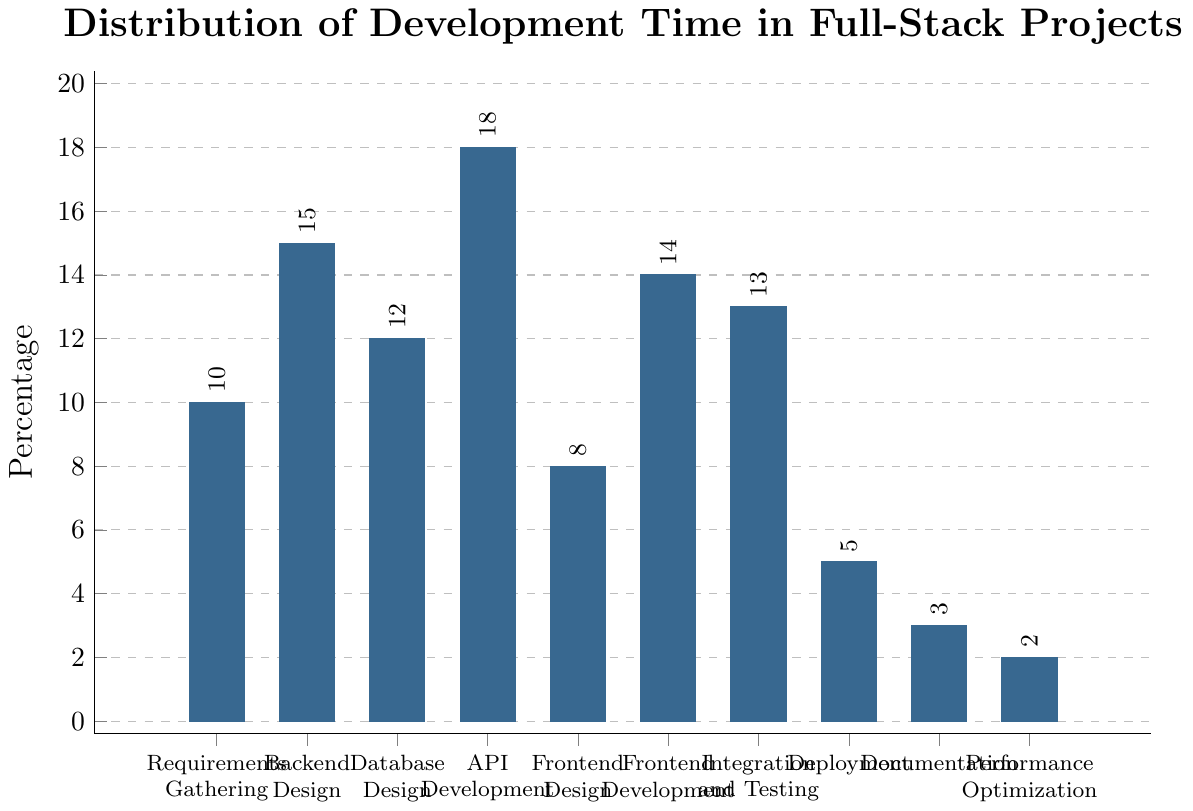What is the highest percentage phase in the development time distribution? The bar representing **API Development** reaches the highest point, indicating it takes up the most significant percentage of the development time. By visually comparing the heights of the bars, we can determine that API Development has the highest percentage.
Answer: API Development Which phase has the lowest percentage in the development time distribution? The shortest bar in the chart represents **Performance Optimization**, indicating that this phase has the lowest percentage of development time. By comparing the heights of all bars, Performance Optimization's is clearly the lowest.
Answer: Performance Optimization How much more time is spent on Backend Design compared to Deployment? The height of the bar for Backend Design is 15%, and for Deployment, it is 5%. Subtracting the percentage for Deployment from Backend Design gives us the additional time spent. So, 15% - 5% = 10%.
Answer: 10% What is the combined percentage of time spent on Design phases (Backend Design, Database Design, Frontend Design)? To find the total percentage spent on design phases, add the percentages for Backend Design (15%), Database Design (12%), and Frontend Design (8%). Thus, 15% + 12% + 8% = 35%.
Answer: 35% Which two phases have a combined percentage closest to that spent on API Development? The API Development phase has a percentage of 18%. To find the two phases that together total close to 18%, we can try various combinations. Integration and Testing (13%) and Performance Optimization (2%) together sum to 15%, which is close. However, Frontend Design (8%) and Frontend Development (14%) sum to 22%, which is even closer.
Answer: Frontend Design and Frontend Development Is the percentage of time spent on Integration and Testing more than that on Database Design? By comparing the heights of the bars, we see that Integration and Testing has a percentage of 13%, while Database Design has 12%. Therefore, Integration and Testing's percentage is slightly higher.
Answer: Yes What is the average percentage of time spent on Requirements Gathering and Documentation? The percentages for Requirements Gathering and Documentation are 10% and 3%, respectively. Adding these together gives 13%, and to find the average, we divide by 2. So, 13% / 2 = 6.5%.
Answer: 6.5% Which phases take up more than 12% of the development time? By examining the chart, the phases with percentages higher than 12% are Backend Design (15%), API Development (18%), Frontend Development (14%), and Integration and Testing (13%).
Answer: Backend Design, API Development, Frontend Development, Integration and Testing What is the difference in the percentage of time spent on Documentation and Performance Optimization? The percentage for Documentation is 3%, and for Performance Optimization, it is 2%. Subtracting the two gives: 3% - 2% = 1%.
Answer: 1% What is the total percentage of time spent on Frontend Design and Development combined? The percentages for Frontend Design and Frontend Development are 8% and 14%, respectively. Adding these gives: 8% + 14% = 22%.
Answer: 22% 